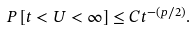Convert formula to latex. <formula><loc_0><loc_0><loc_500><loc_500>P \left [ t < U < \infty \right ] \leq C { t ^ { - ( p / 2 ) } } .</formula> 